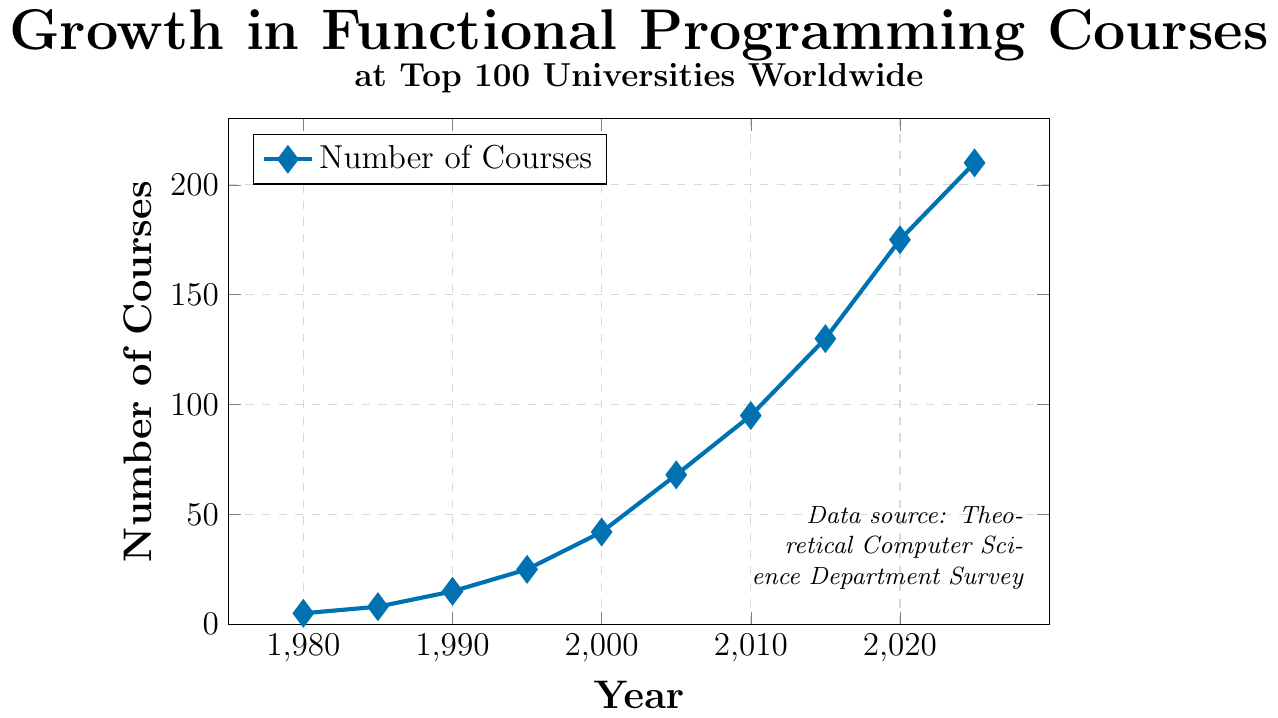What was the number of courses offered in 2000? Look at the year 2000 on the x-axis and find the corresponding point on the plot. Read the value on the y-axis.
Answer: 42 By how much did the number of courses increase between 1990 and 2005? Find the y-values for the years 1990 and 2005. The number of courses in 1990 was 15 and in 2005 it was 68. Subtract the number in 1990 from the number in 2005: 68 - 15.
Answer: 53 What is the average number of courses offered in 2010, 2015, and 2020? Find the y-values for the years 2010, 2015, and 2020, which are 95, 130, and 175 respectively. Then, calculate the average by summing the values and dividing by 3: (95 + 130 + 175) / 3.
Answer: 133.33 Which year saw a faster growth rate: from 1990 to 2000 or from 2005 to 2015? Calculate the difference in the number of courses for the periods 1990-2000 (42-15) and 2005-2015 (130-68). Then compute the growth rate by dividing each result by 10 years: (42-15)/10 and (130-68)/10. Compare the two rates: (27/10) and (62/10).
Answer: 2005 to 2015 What is the trend in the number of courses from 1980 to 2025? Observe the overall direction of the line chart from year 1980 to 2025. The number of courses starts from a low value, consistently increases, and reaches a higher value by 2025.
Answer: Increasing How many courses were offered in 1980 compared to 2025? Look at the y-values for the years 1980 and 2025, which are 5 and 210 respectively. Compare these two values.
Answer: 1980 had 5 courses, 2025 had 210 courses What is the difference in the number of courses offered between 2015 and 2020? Identify the number of courses offered in 2015 and 2020. Subtract the number in 2015 from the number in 2020: 175 - 130.
Answer: 45 How many more courses were there in 1985 compared to 1980? Find the y-values for the years 1980 and 1985. Subtract the number in 1980 from the number in 1985: 8 - 5.
Answer: 3 Which year had twice the number of courses offered as in 1995? Find the number of courses in 1995, which is 25. Look for the year where the number of courses is approximately twice this value (50). The closest year is 2000 with 42 courses.
Answer: None 